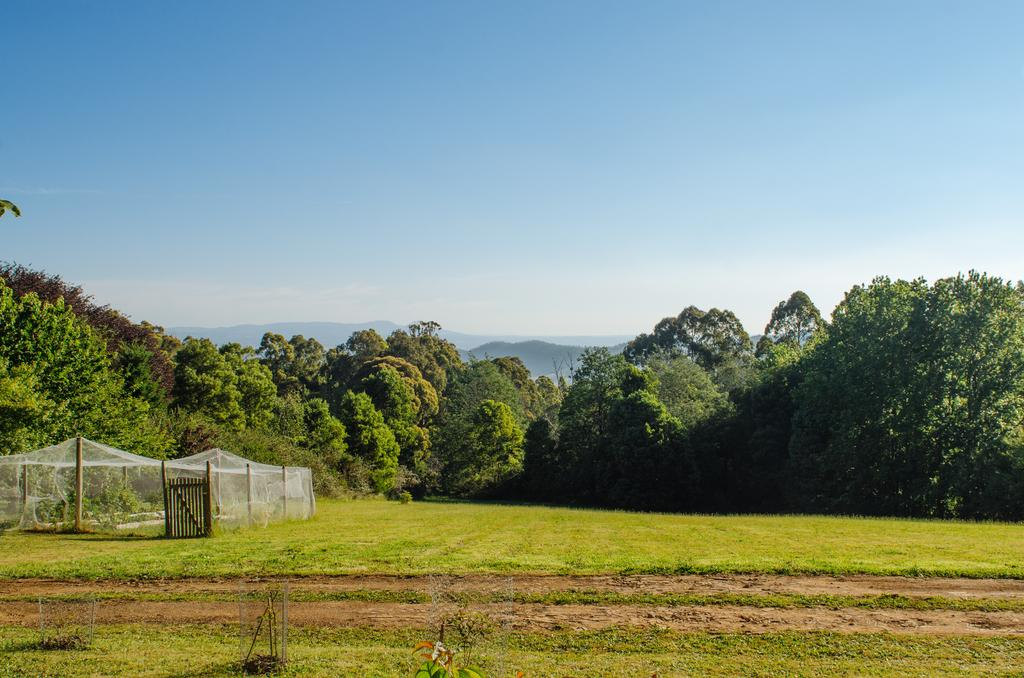What type of natural elements can be seen in the image? There are trees and plants in the image. What man-made structures are present in the image? There are poles, a net, and a wooden railing in the image. What type of landscape feature is visible in the distance? There are mountains visible in the image. What part of the natural environment is visible in the image? The sky is visible in the image. What type of cave can be seen in the image? There is no cave present in the image. How does the wooden railing express its feelings of hate in the image? The wooden railing does not express any feelings, as it is an inanimate object. 